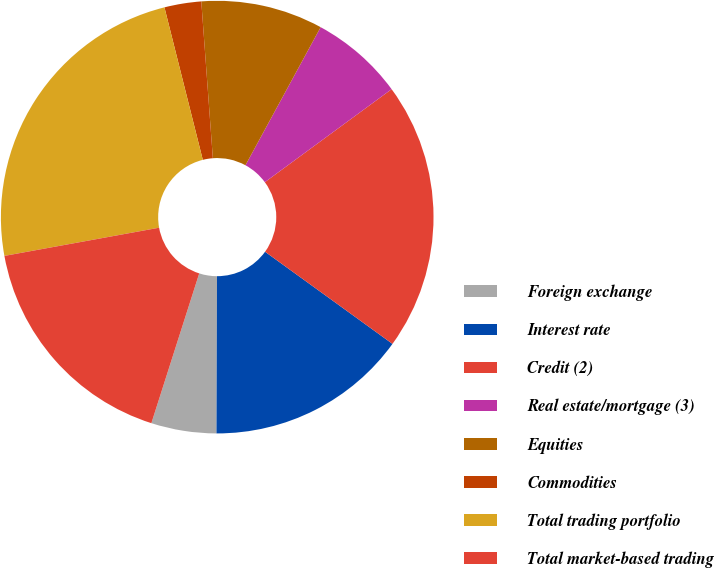Convert chart. <chart><loc_0><loc_0><loc_500><loc_500><pie_chart><fcel>Foreign exchange<fcel>Interest rate<fcel>Credit (2)<fcel>Real estate/mortgage (3)<fcel>Equities<fcel>Commodities<fcel>Total trading portfolio<fcel>Total market-based trading<nl><fcel>4.87%<fcel>15.09%<fcel>20.04%<fcel>6.99%<fcel>9.11%<fcel>2.75%<fcel>23.95%<fcel>17.21%<nl></chart> 